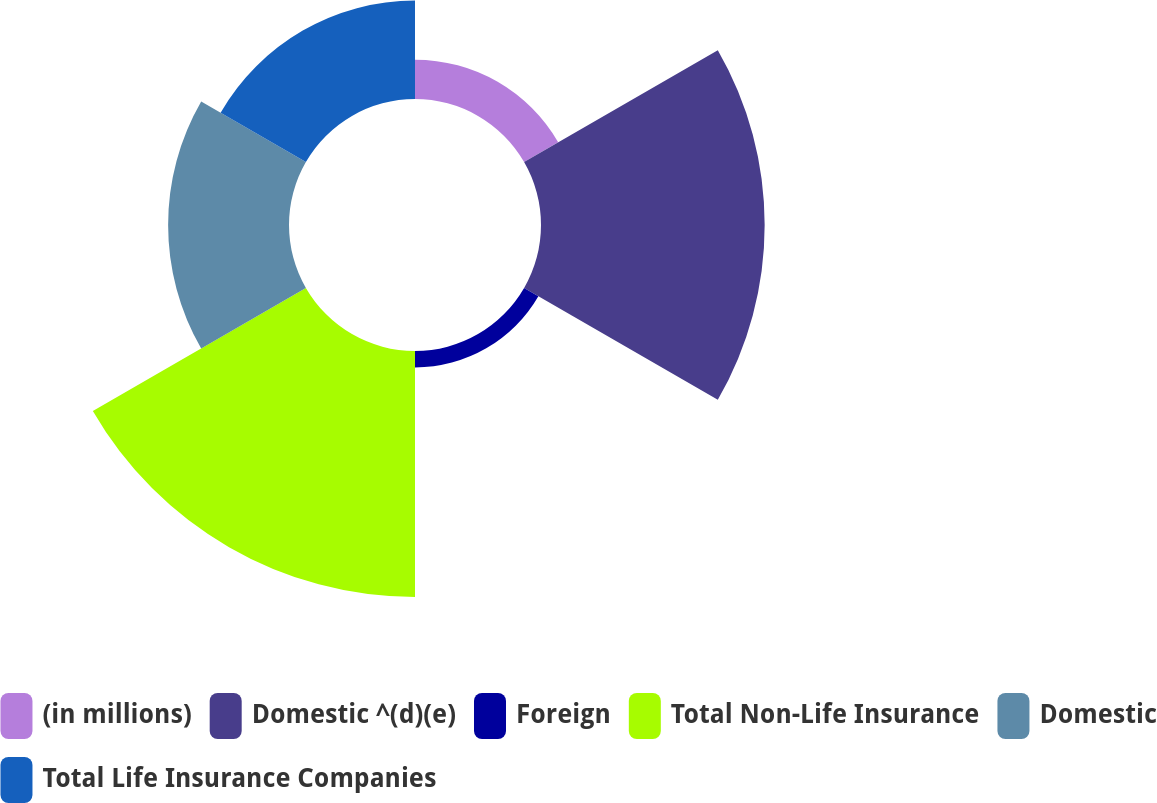<chart> <loc_0><loc_0><loc_500><loc_500><pie_chart><fcel>(in millions)<fcel>Domestic ^(d)(e)<fcel>Foreign<fcel>Total Non-Life Insurance<fcel>Domestic<fcel>Total Life Insurance Companies<nl><fcel>5.28%<fcel>30.03%<fcel>2.21%<fcel>33.03%<fcel>16.23%<fcel>13.22%<nl></chart> 